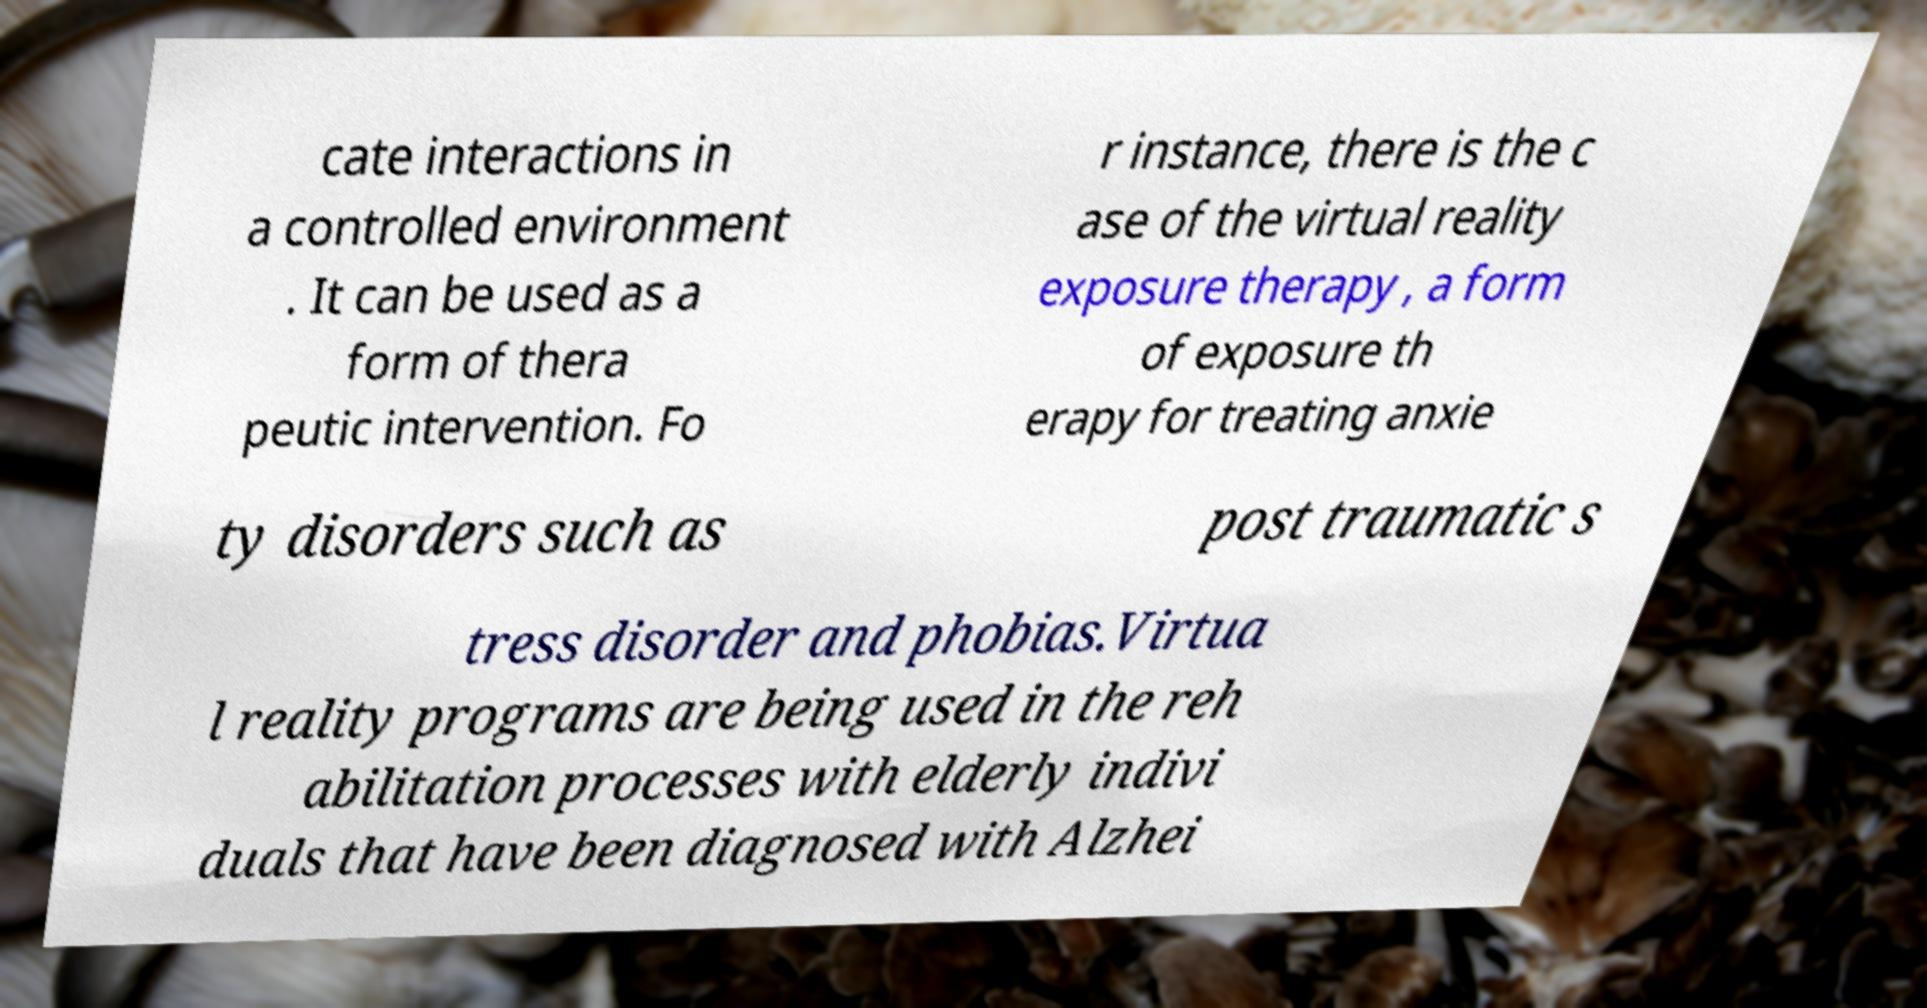Could you assist in decoding the text presented in this image and type it out clearly? cate interactions in a controlled environment . It can be used as a form of thera peutic intervention. Fo r instance, there is the c ase of the virtual reality exposure therapy , a form of exposure th erapy for treating anxie ty disorders such as post traumatic s tress disorder and phobias.Virtua l reality programs are being used in the reh abilitation processes with elderly indivi duals that have been diagnosed with Alzhei 